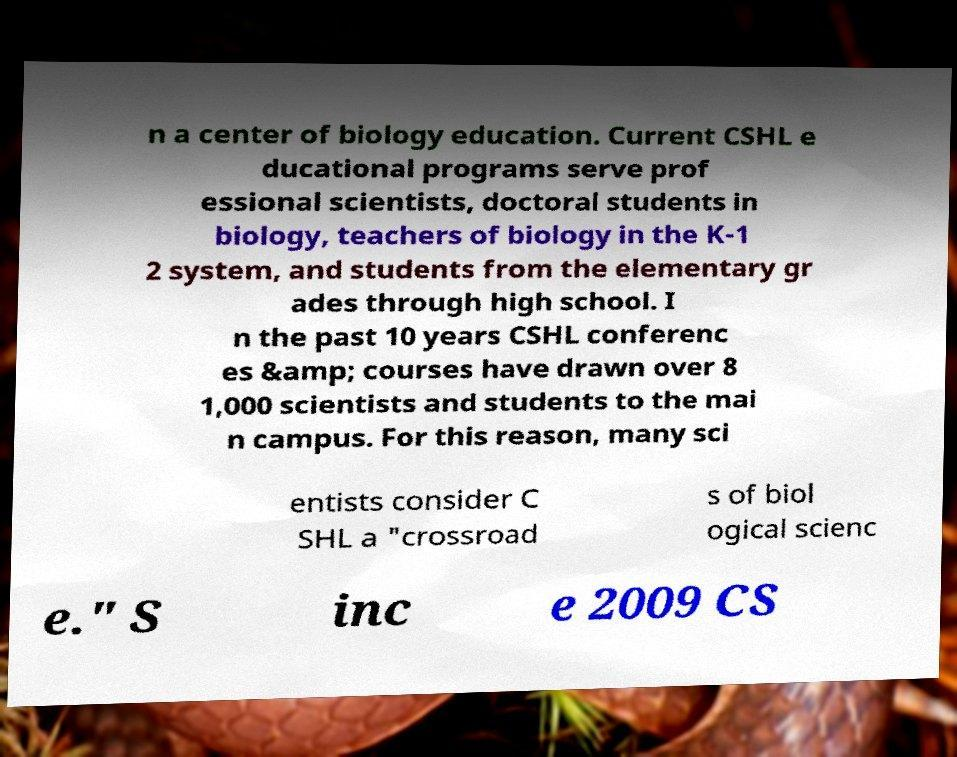Could you extract and type out the text from this image? n a center of biology education. Current CSHL e ducational programs serve prof essional scientists, doctoral students in biology, teachers of biology in the K-1 2 system, and students from the elementary gr ades through high school. I n the past 10 years CSHL conferenc es &amp; courses have drawn over 8 1,000 scientists and students to the mai n campus. For this reason, many sci entists consider C SHL a "crossroad s of biol ogical scienc e." S inc e 2009 CS 